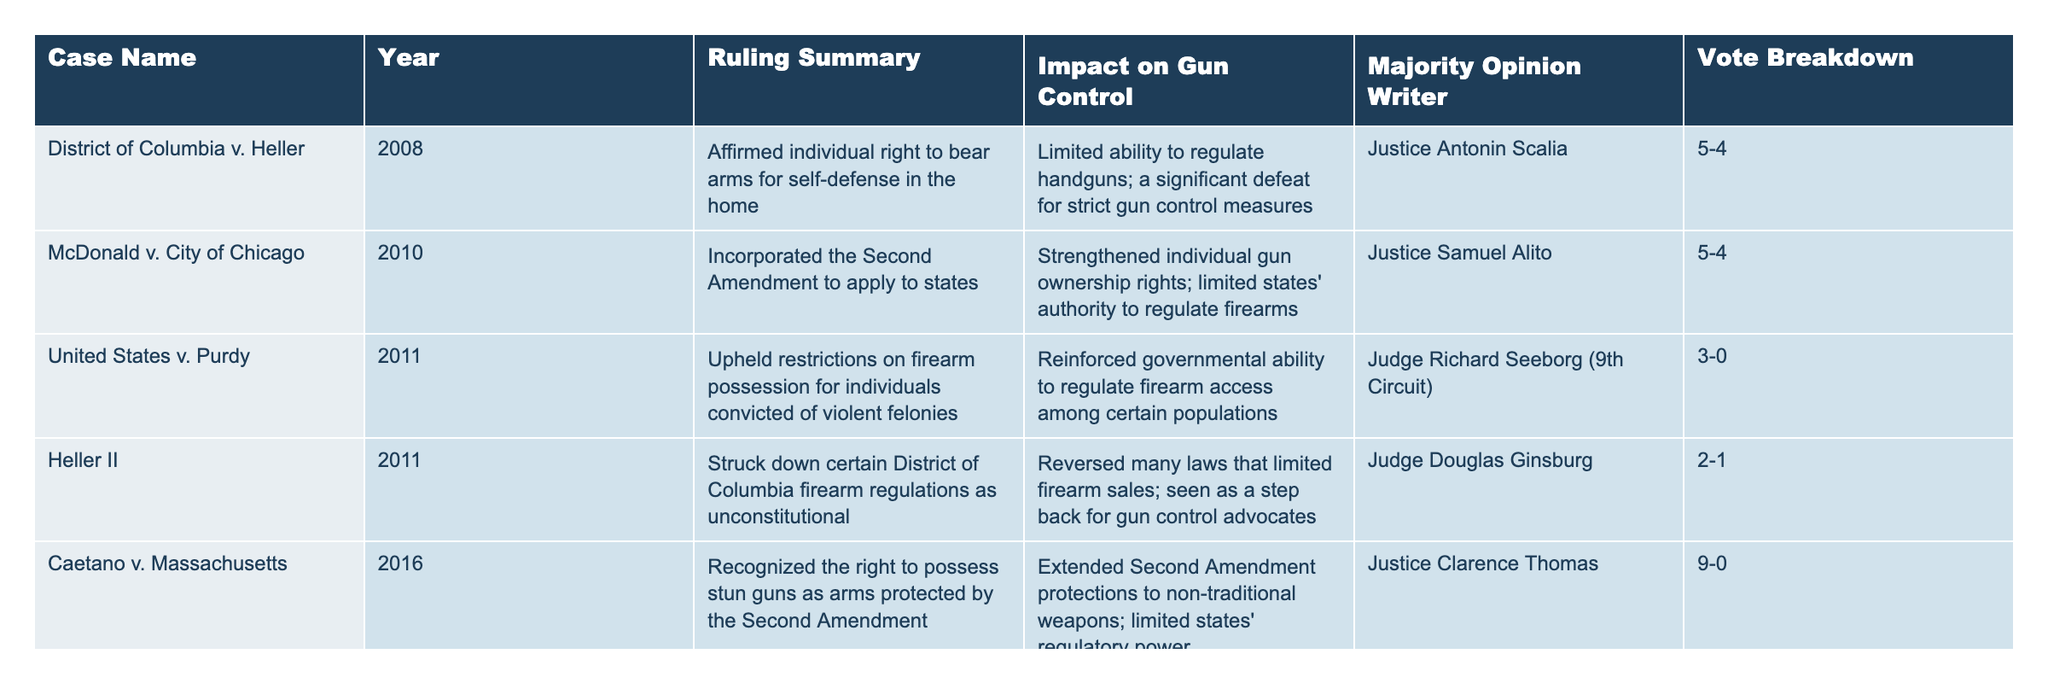What is the ruling year for the case McDonald v. City of Chicago? The table lists McDonald v. City of Chicago under the Year column, which shows that it was ruled in 2010.
Answer: 2010 Who wrote the majority opinion for District of Columbia v. Heller? The table indicates that Justice Antonin Scalia wrote the majority opinion for District of Columbia v. Heller.
Answer: Justice Antonin Scalia What was the impact of the case Caetano v. Massachusetts on gun control? According to the table, Caetano v. Massachusetts extended Second Amendment protections to non-traditional weapons and limited states' regulatory power, which is a slight step back for gun control measures.
Answer: Extended protections, limited state regulation How many rulings had a vote breakdown of 5-4? The table shows two cases with a 5-4 vote breakdown: District of Columbia v. Heller and McDonald v. City of Chicago. Thus, the total is 2.
Answer: 2 Which case had the largest majority in support of a ruling? Caetano v. Massachusetts had a unanimous ruling with a 9-0 vote breakdown, indicating the largest majority in support of that decision.
Answer: Caetano v. Massachusetts What is the combined impact on gun control from the cases Heller II and New York State Rifle & Pistol Association v. Bruen? Heller II reversed many laws limiting firearm sales, while New York State Rifle & Pistol Association v. Bruen significantly expanded individual rights to carry firearms. Combining these impacts suggests a trend towards less regulation and more rights for gun owners.
Answer: Limited regulation; expanded rights Is it true that all majorities in these cases supported gun ownership rights? Not all majorities supported gun ownership rights. United States v. Purdy upheld restrictions on firearm possession for individuals convicted of violent felonies, indicating some governmental authority to regulate firearms.
Answer: False What year saw two significant rulings on the Second Amendment? The years 2011 saw United States v. Purdy and Heller II, both significant rulings regarding the Second Amendment.
Answer: 2011 What would the average vote breakdown of the cases be, if considered as fractions? The votes can be seen as fractions: 5/4 for two cases, 3/0 for one case, 2/1 for one case, 9/0 for one case, and 6/3 for one case. A total of 5 equivalent cases leads to an average of 5.8/4, calculated by summing the numerators (5+5+3+2+9+6=30) and denominators (4+4+0+1+0+3=12). This gives us an unweighted average of approximately 30/12 or 2.5 for numerators versus 1 for denominators, leading to an approximate average breakdown of 2.5/1.
Answer: Approximately 2.5/1 Which case had a ruling that most broadly expanded gun ownership rights? New York State Rifle & Pistol Association v. Bruen significantly expanded individual rights to carry firearms, marking it as the broadest expansion of gun ownership rights.
Answer: New York State Rifle & Pistol Association v. Bruen 